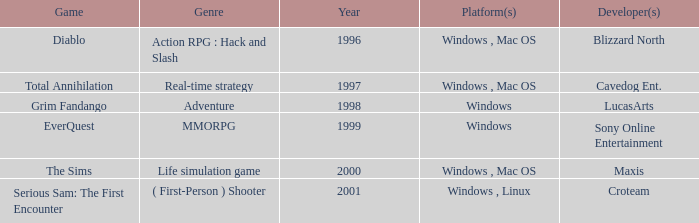What year is the Grim Fandango with a windows platform? 1998.0. 